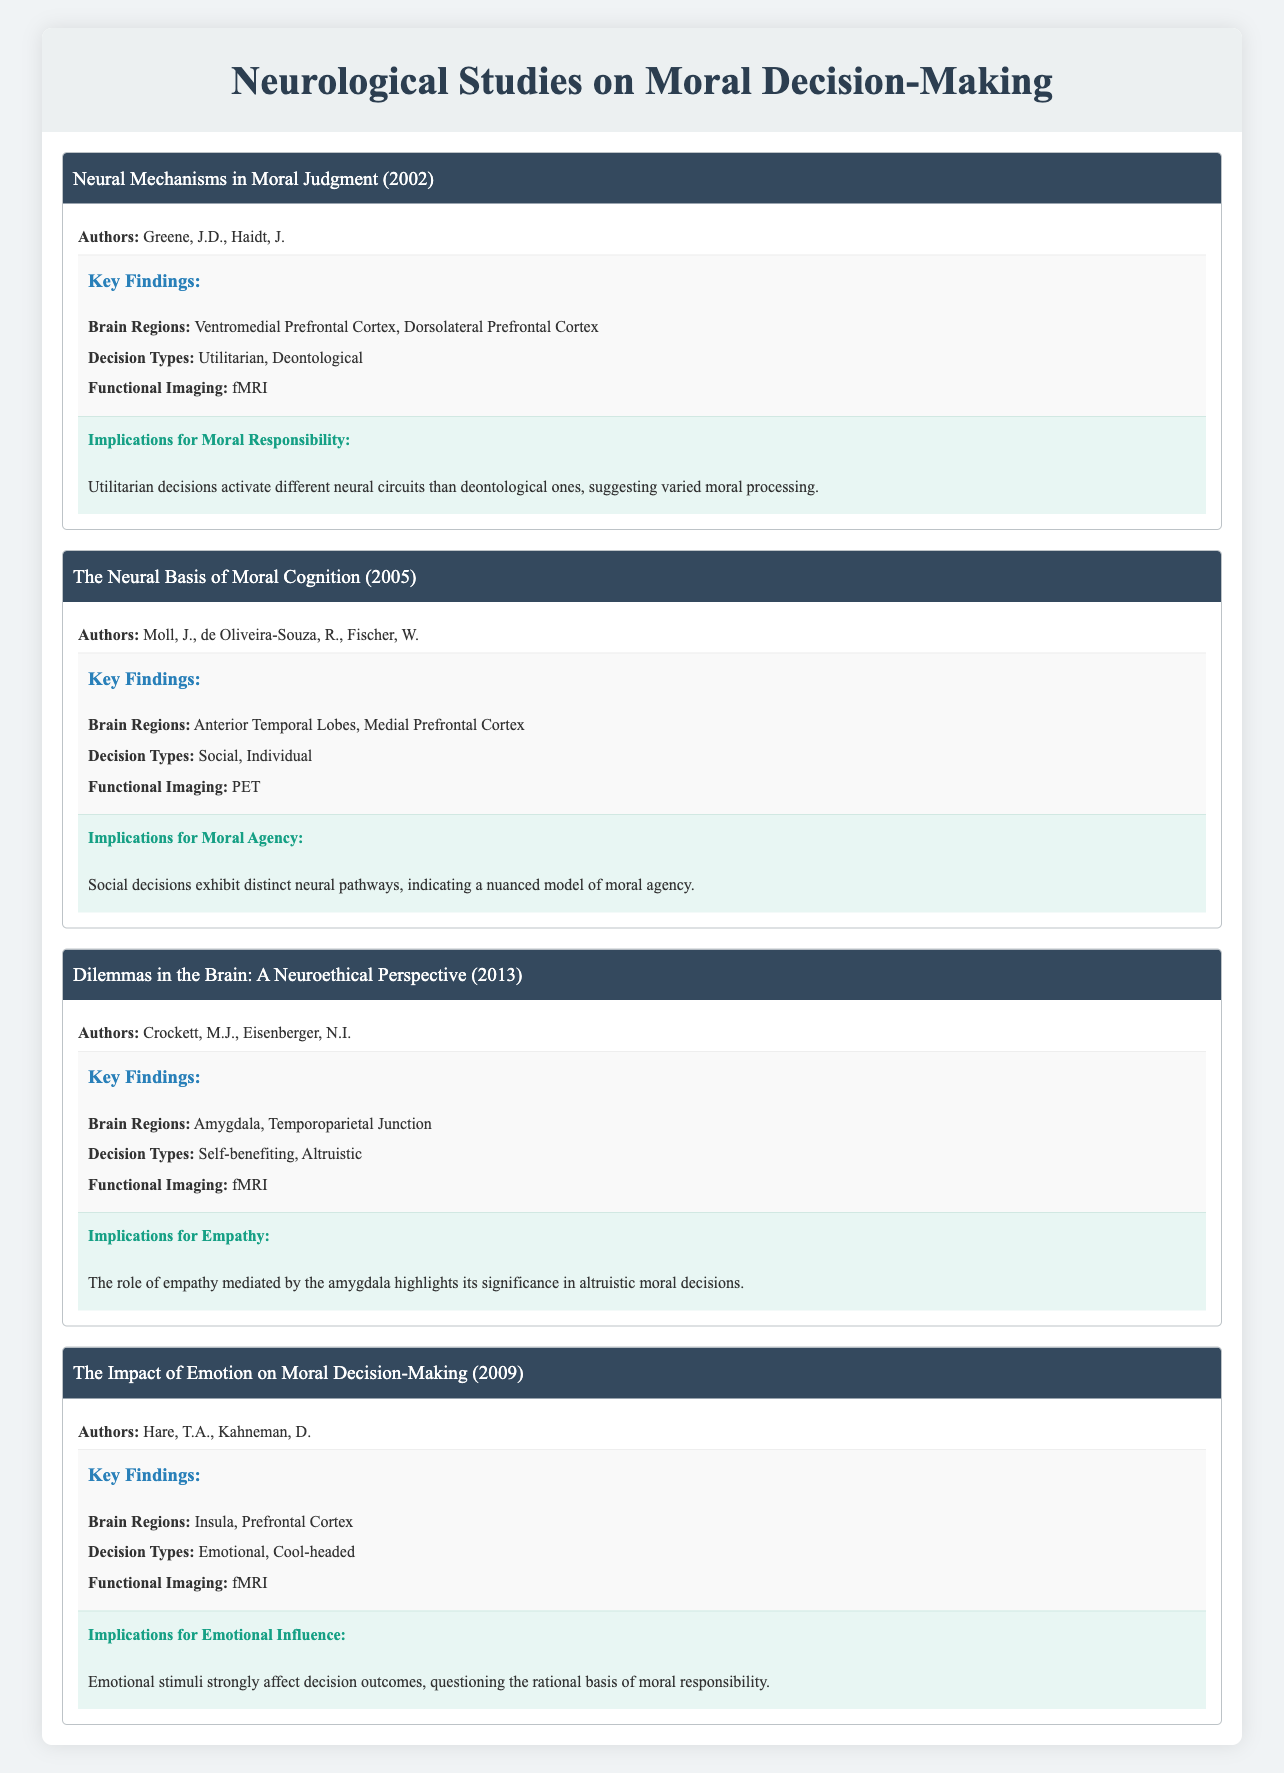What are the main brain regions involved in the study titled "Neural Mechanisms in Moral Judgment"? The study identifies the Ventromedial Prefrontal Cortex and Dorsolateral Prefrontal Cortex as the main brain regions involved. This information is directly accessible in the "Key Findings" section of the respective study in the table.
Answer: Ventromedial Prefrontal Cortex, Dorsolateral Prefrontal Cortex Which year was the study "The Impact of Emotion on Moral Decision-Making" published? The publication year is provided in the study's details. Looking at the respective study in the table, it shows that it was published in 2009.
Answer: 2009 True or False: The study "Dilemmas in the Brain: A Neuroethical Perspective" uses PET imaging. The table specifically notes that this study utilized fMRI for functional imaging. Therefore, the statement is incorrect.
Answer: False What is the overall implication regarding moral responsibility from the study "Neural Mechanisms in Moral Judgment"? The implication indicates that utilitarian decisions activate different neural circuits compared to deontological ones, suggesting that moral processing is associated with varying neural activities. This conclusion is drawn from the implications section of the study.
Answer: Different neural circuits for different decisions How many studies utilize fMRI for functional imaging, and which studies are they? From the table, the studies using fMRI are "Neural Mechanisms in Moral Judgment," "Dilemmas in the Brain: A Neuroethical Perspective," and "The Impact of Emotion on Moral Decision-Making." There are a total of three studies.
Answer: 3 studies: "Neural Mechanisms in Moral Judgment," "Dilemmas in the Brain: A Neuroethical Perspective," "The Impact of Emotion on Moral Decision-Making." What differences in decision types can be noted in the studies and what implications do they have? Analyzing the studies, we see various decision types such as Utilitarian, Deontological, Social, Individual, Self-benefiting, Altruistic, Emotional, and Cool-headed. The implications suggest a distinct neural processing model for different decision-making contexts, indicating that understanding moral judgments is complex and multifaceted. Therefore, the differences highlight the significance of context in moral reasoning.
Answer: Various decision types suggest complex moral reasoning influenced by context 